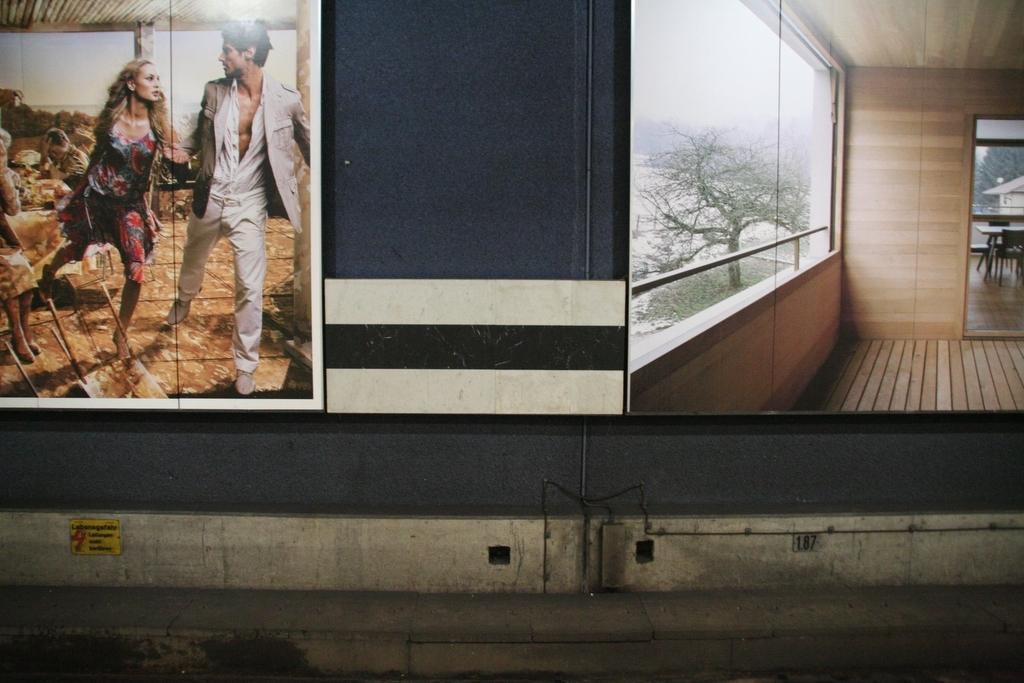Could you give a brief overview of what you see in this image? In this image we can see wall hanging attached to the wall, dining table, trees and sky. 